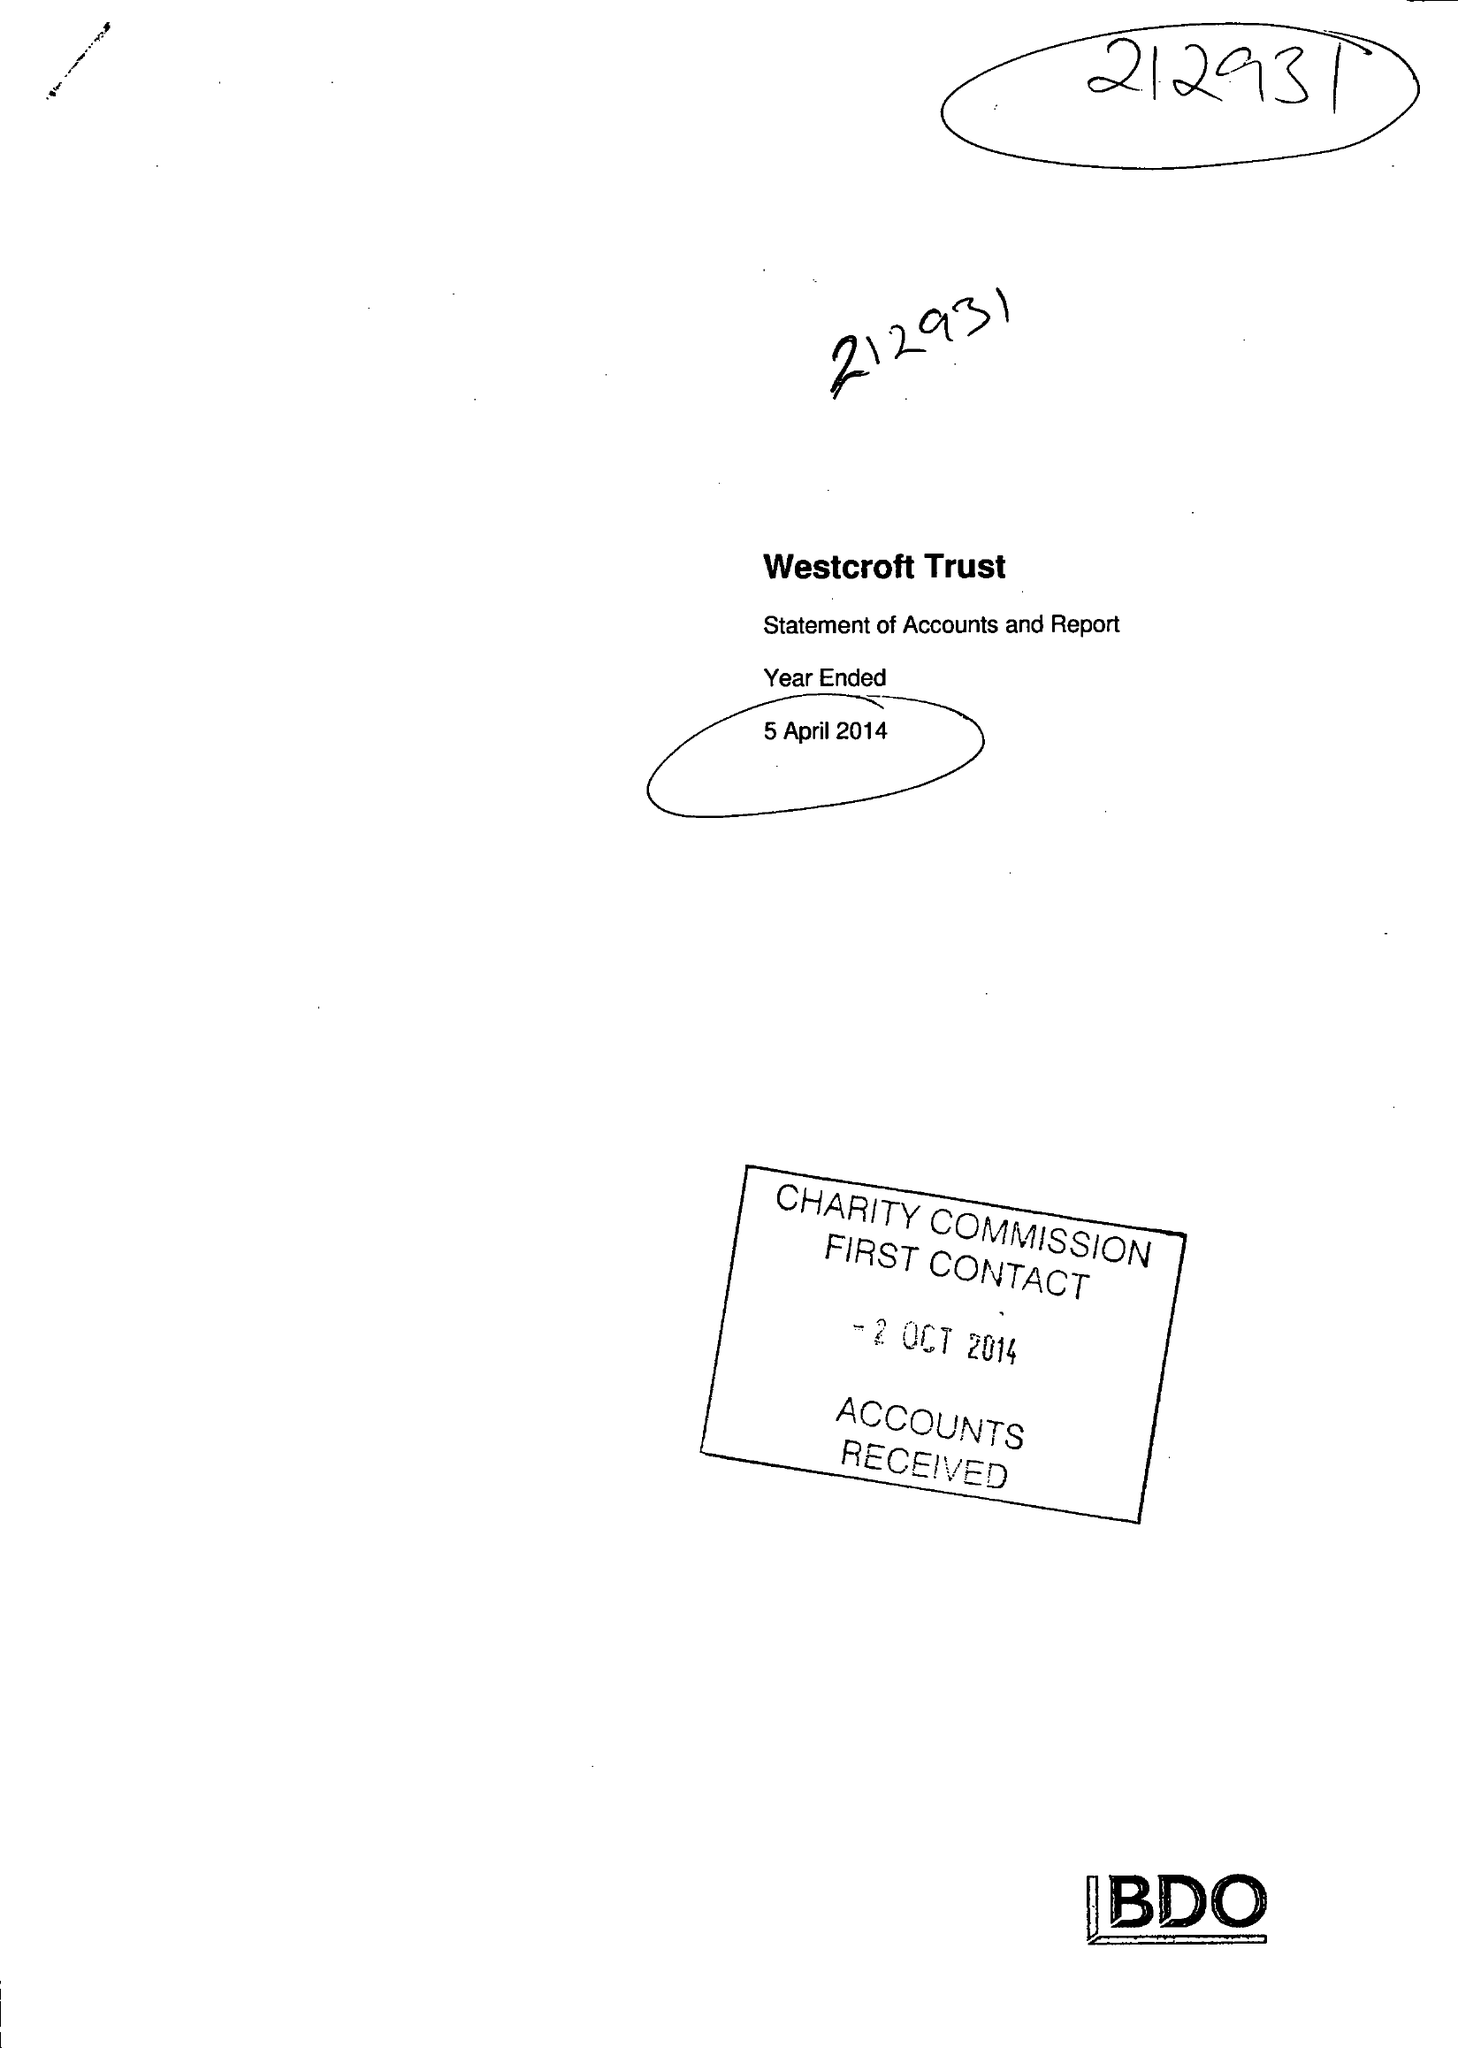What is the value for the address__post_town?
Answer the question using a single word or phrase. OSWESTRY 